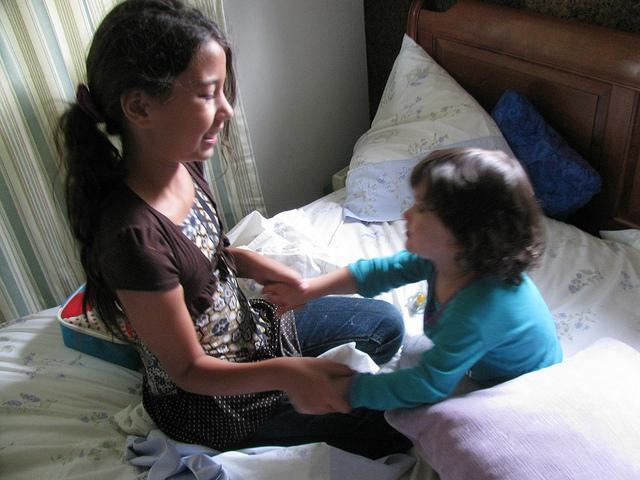How many people are visible?
Give a very brief answer. 2. How many vans follows the bus in a given image?
Give a very brief answer. 0. 